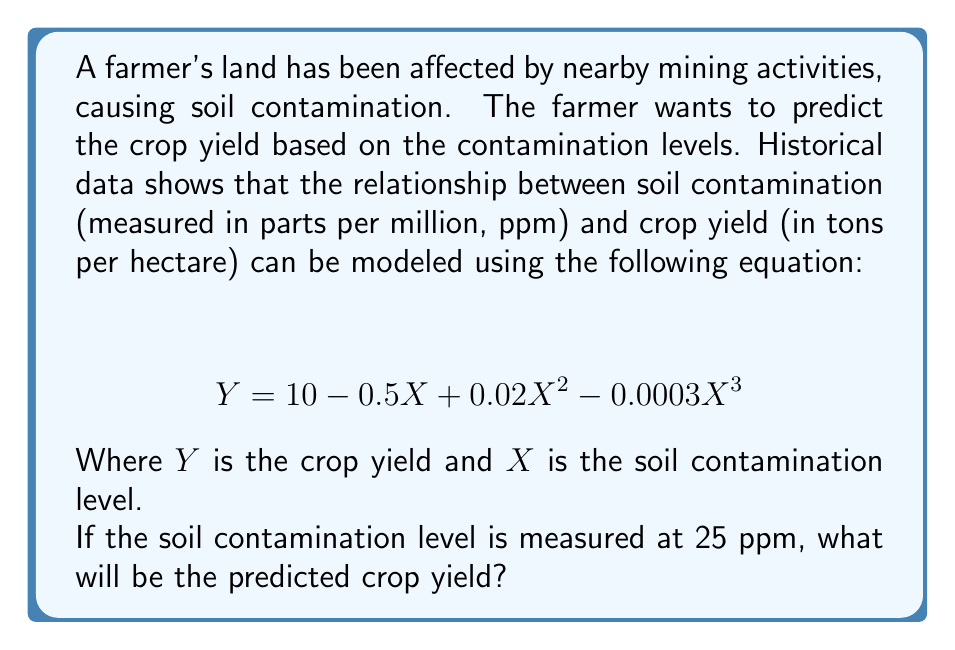Can you solve this math problem? To solve this problem, we need to substitute the given soil contamination level into the equation and calculate the result.

Given:
- Soil contamination level, $X = 25$ ppm
- Crop yield equation: $Y = 10 - 0.5X + 0.02X^2 - 0.0003X^3$

Let's substitute $X = 25$ into the equation:

$$ Y = 10 - 0.5(25) + 0.02(25)^2 - 0.0003(25)^3 $$

Now, let's calculate each term:

1. $10$ remains as is
2. $-0.5(25) = -12.5$
3. $0.02(25)^2 = 0.02(625) = 12.5$
4. $-0.0003(25)^3 = -0.0003(15625) = -4.6875$

Adding all these terms:

$$ Y = 10 - 12.5 + 12.5 - 4.6875 $$

$$ Y = 5.3125 $$

Therefore, the predicted crop yield is 5.3125 tons per hectare.
Answer: 5.3125 tons per hectare 